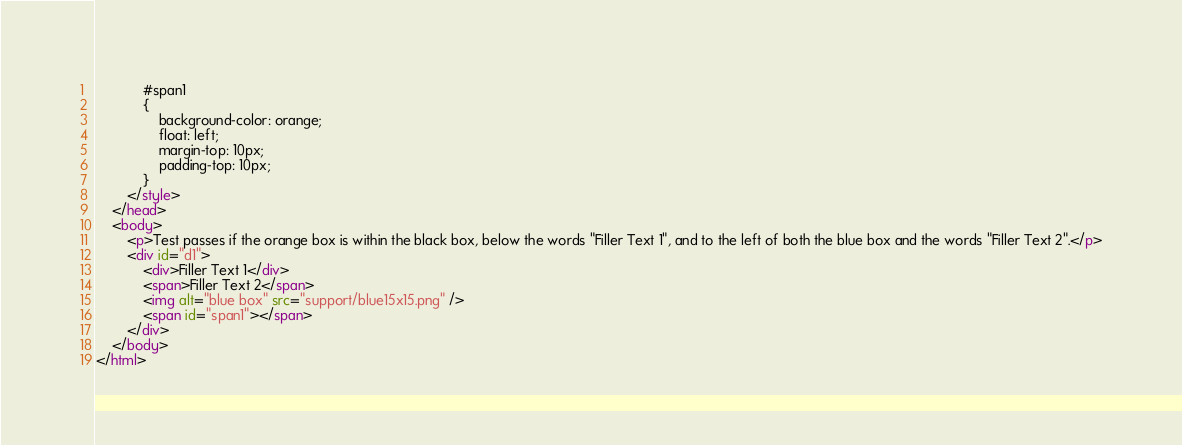Convert code to text. <code><loc_0><loc_0><loc_500><loc_500><_HTML_>            #span1
            {
                background-color: orange;
                float: left;
                margin-top: 10px;
                padding-top: 10px;
            }
        </style>
    </head>
    <body>
        <p>Test passes if the orange box is within the black box, below the words "Filler Text 1", and to the left of both the blue box and the words "Filler Text 2".</p>
        <div id="d1">
            <div>Filler Text 1</div>
            <span>Filler Text 2</span>
            <img alt="blue box" src="support/blue15x15.png" />
            <span id="span1"></span>
        </div>
    </body>
</html></code> 